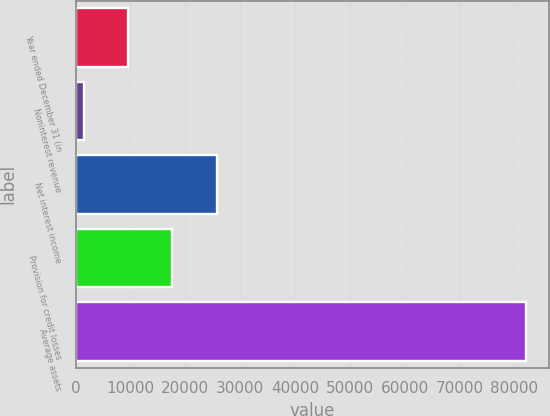<chart> <loc_0><loc_0><loc_500><loc_500><bar_chart><fcel>Year ended December 31 (in<fcel>Noninterest revenue<fcel>Net interest income<fcel>Provision for credit losses<fcel>Average assets<nl><fcel>9567.9<fcel>1494<fcel>25715.7<fcel>17641.8<fcel>82233<nl></chart> 